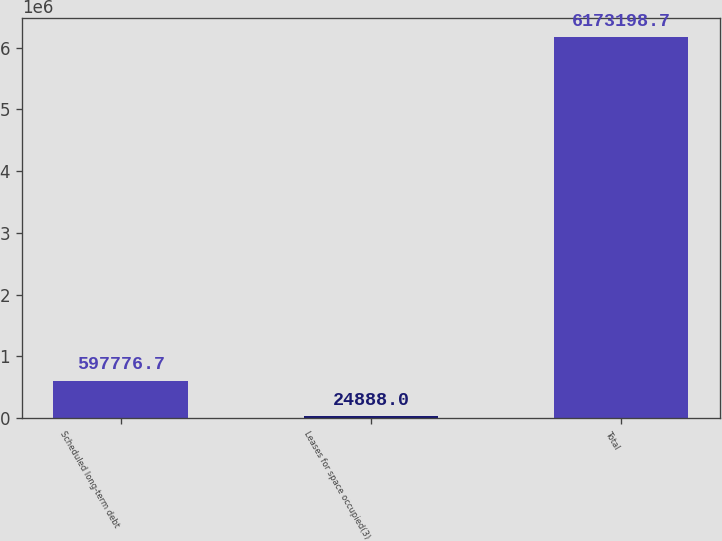Convert chart to OTSL. <chart><loc_0><loc_0><loc_500><loc_500><bar_chart><fcel>Scheduled long-term debt<fcel>Leases for space occupied(3)<fcel>Total<nl><fcel>597777<fcel>24888<fcel>6.1732e+06<nl></chart> 